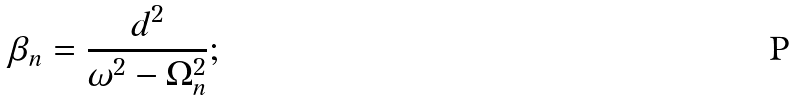Convert formula to latex. <formula><loc_0><loc_0><loc_500><loc_500>\beta _ { n } = \frac { d ^ { 2 } } { \omega ^ { 2 } - \Omega _ { n } ^ { 2 } } ;</formula> 